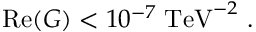Convert formula to latex. <formula><loc_0><loc_0><loc_500><loc_500>R e ( G ) < 1 0 ^ { - 7 } \, T e V ^ { - 2 } \ .</formula> 